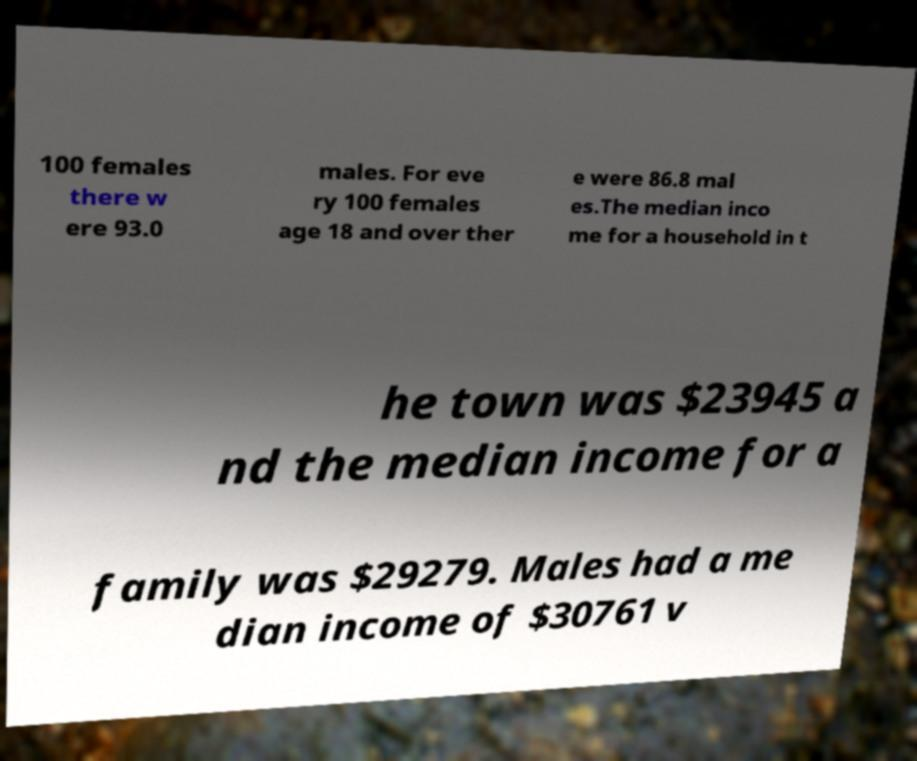Could you assist in decoding the text presented in this image and type it out clearly? 100 females there w ere 93.0 males. For eve ry 100 females age 18 and over ther e were 86.8 mal es.The median inco me for a household in t he town was $23945 a nd the median income for a family was $29279. Males had a me dian income of $30761 v 